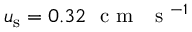<formula> <loc_0><loc_0><loc_500><loc_500>u _ { s } = 0 . 3 2 c m s ^ { - 1 }</formula> 